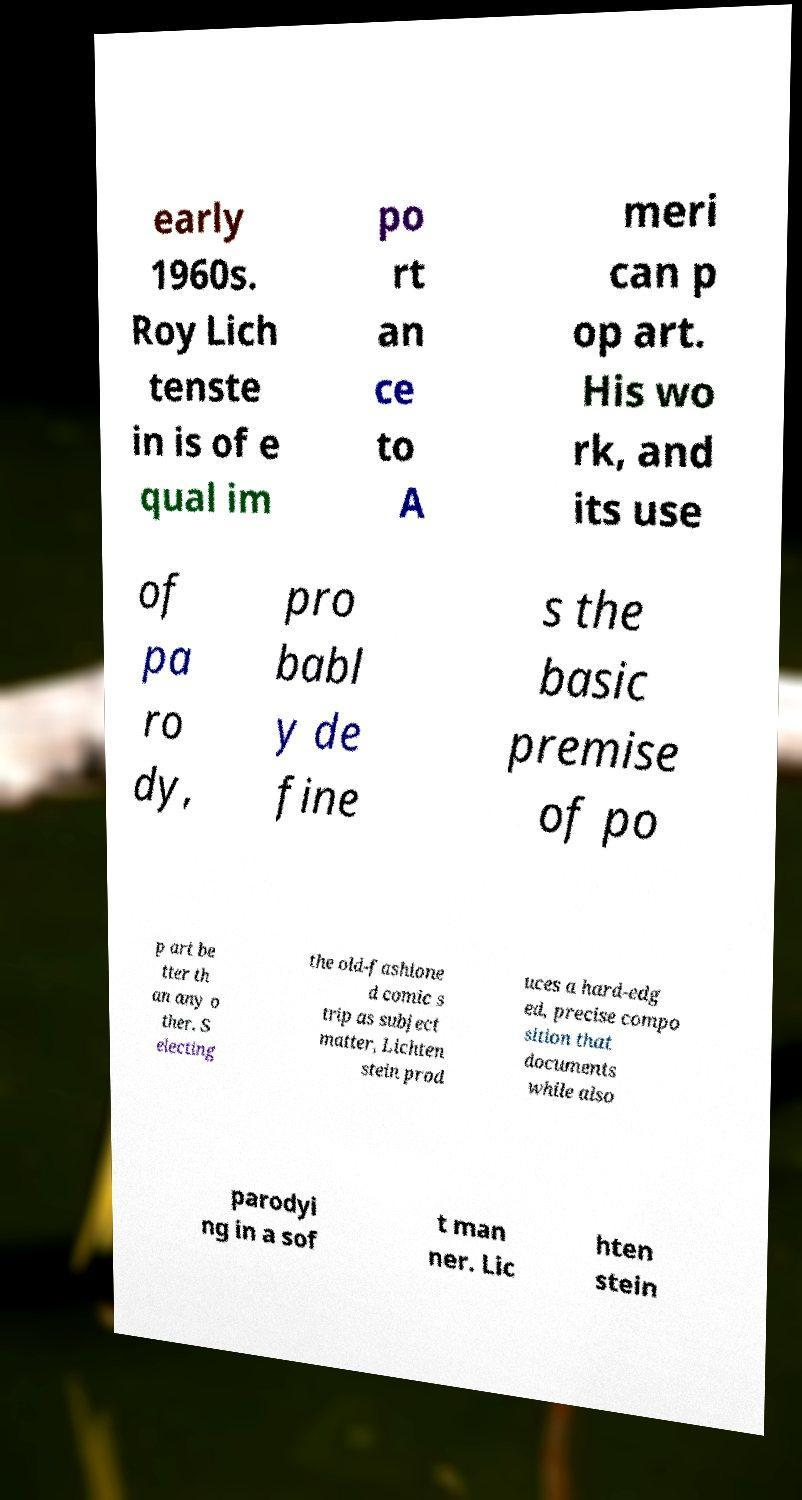Could you extract and type out the text from this image? early 1960s. Roy Lich tenste in is of e qual im po rt an ce to A meri can p op art. His wo rk, and its use of pa ro dy, pro babl y de fine s the basic premise of po p art be tter th an any o ther. S electing the old-fashione d comic s trip as subject matter, Lichten stein prod uces a hard-edg ed, precise compo sition that documents while also parodyi ng in a sof t man ner. Lic hten stein 